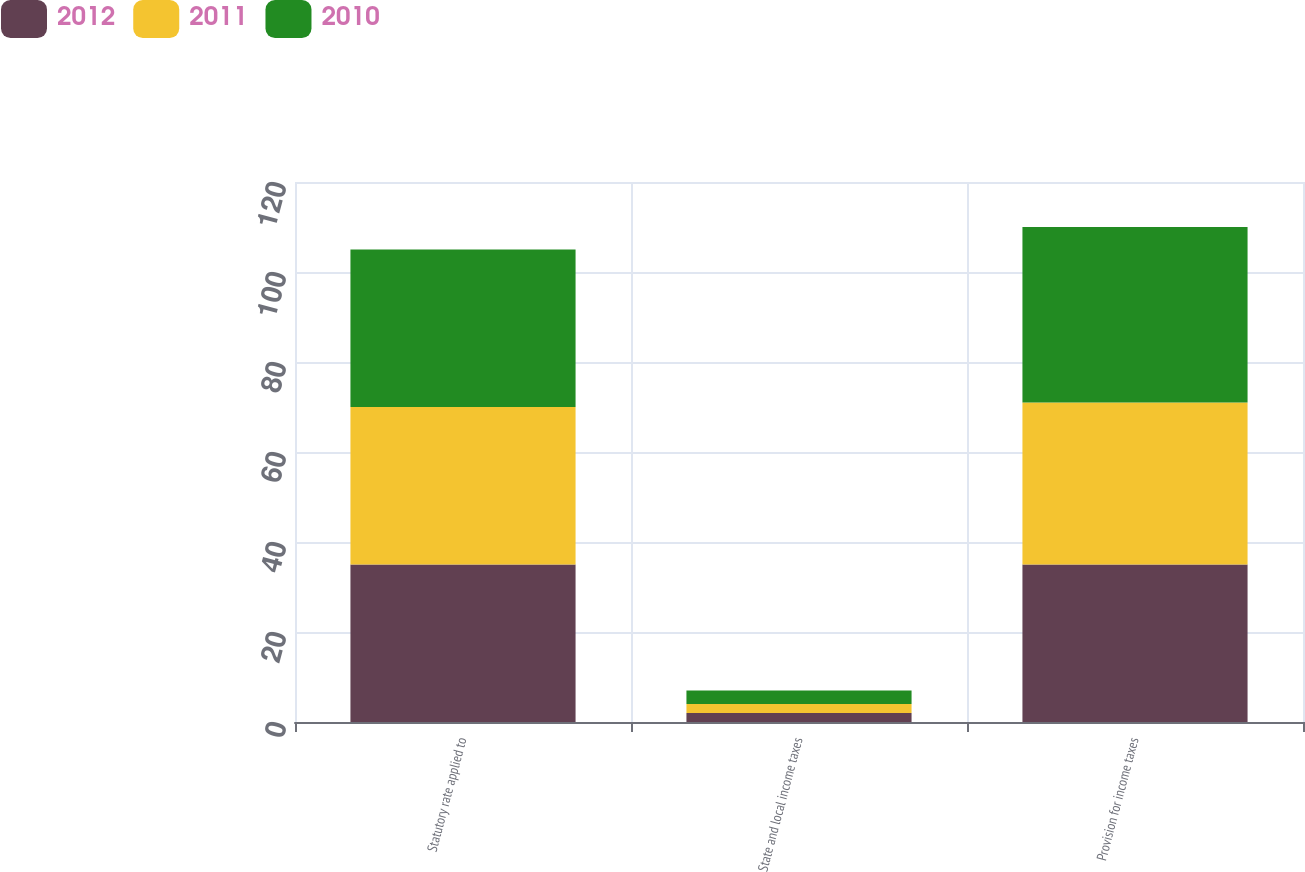Convert chart. <chart><loc_0><loc_0><loc_500><loc_500><stacked_bar_chart><ecel><fcel>Statutory rate applied to<fcel>State and local income taxes<fcel>Provision for income taxes<nl><fcel>2012<fcel>35<fcel>2<fcel>35<nl><fcel>2011<fcel>35<fcel>2<fcel>36<nl><fcel>2010<fcel>35<fcel>3<fcel>39<nl></chart> 